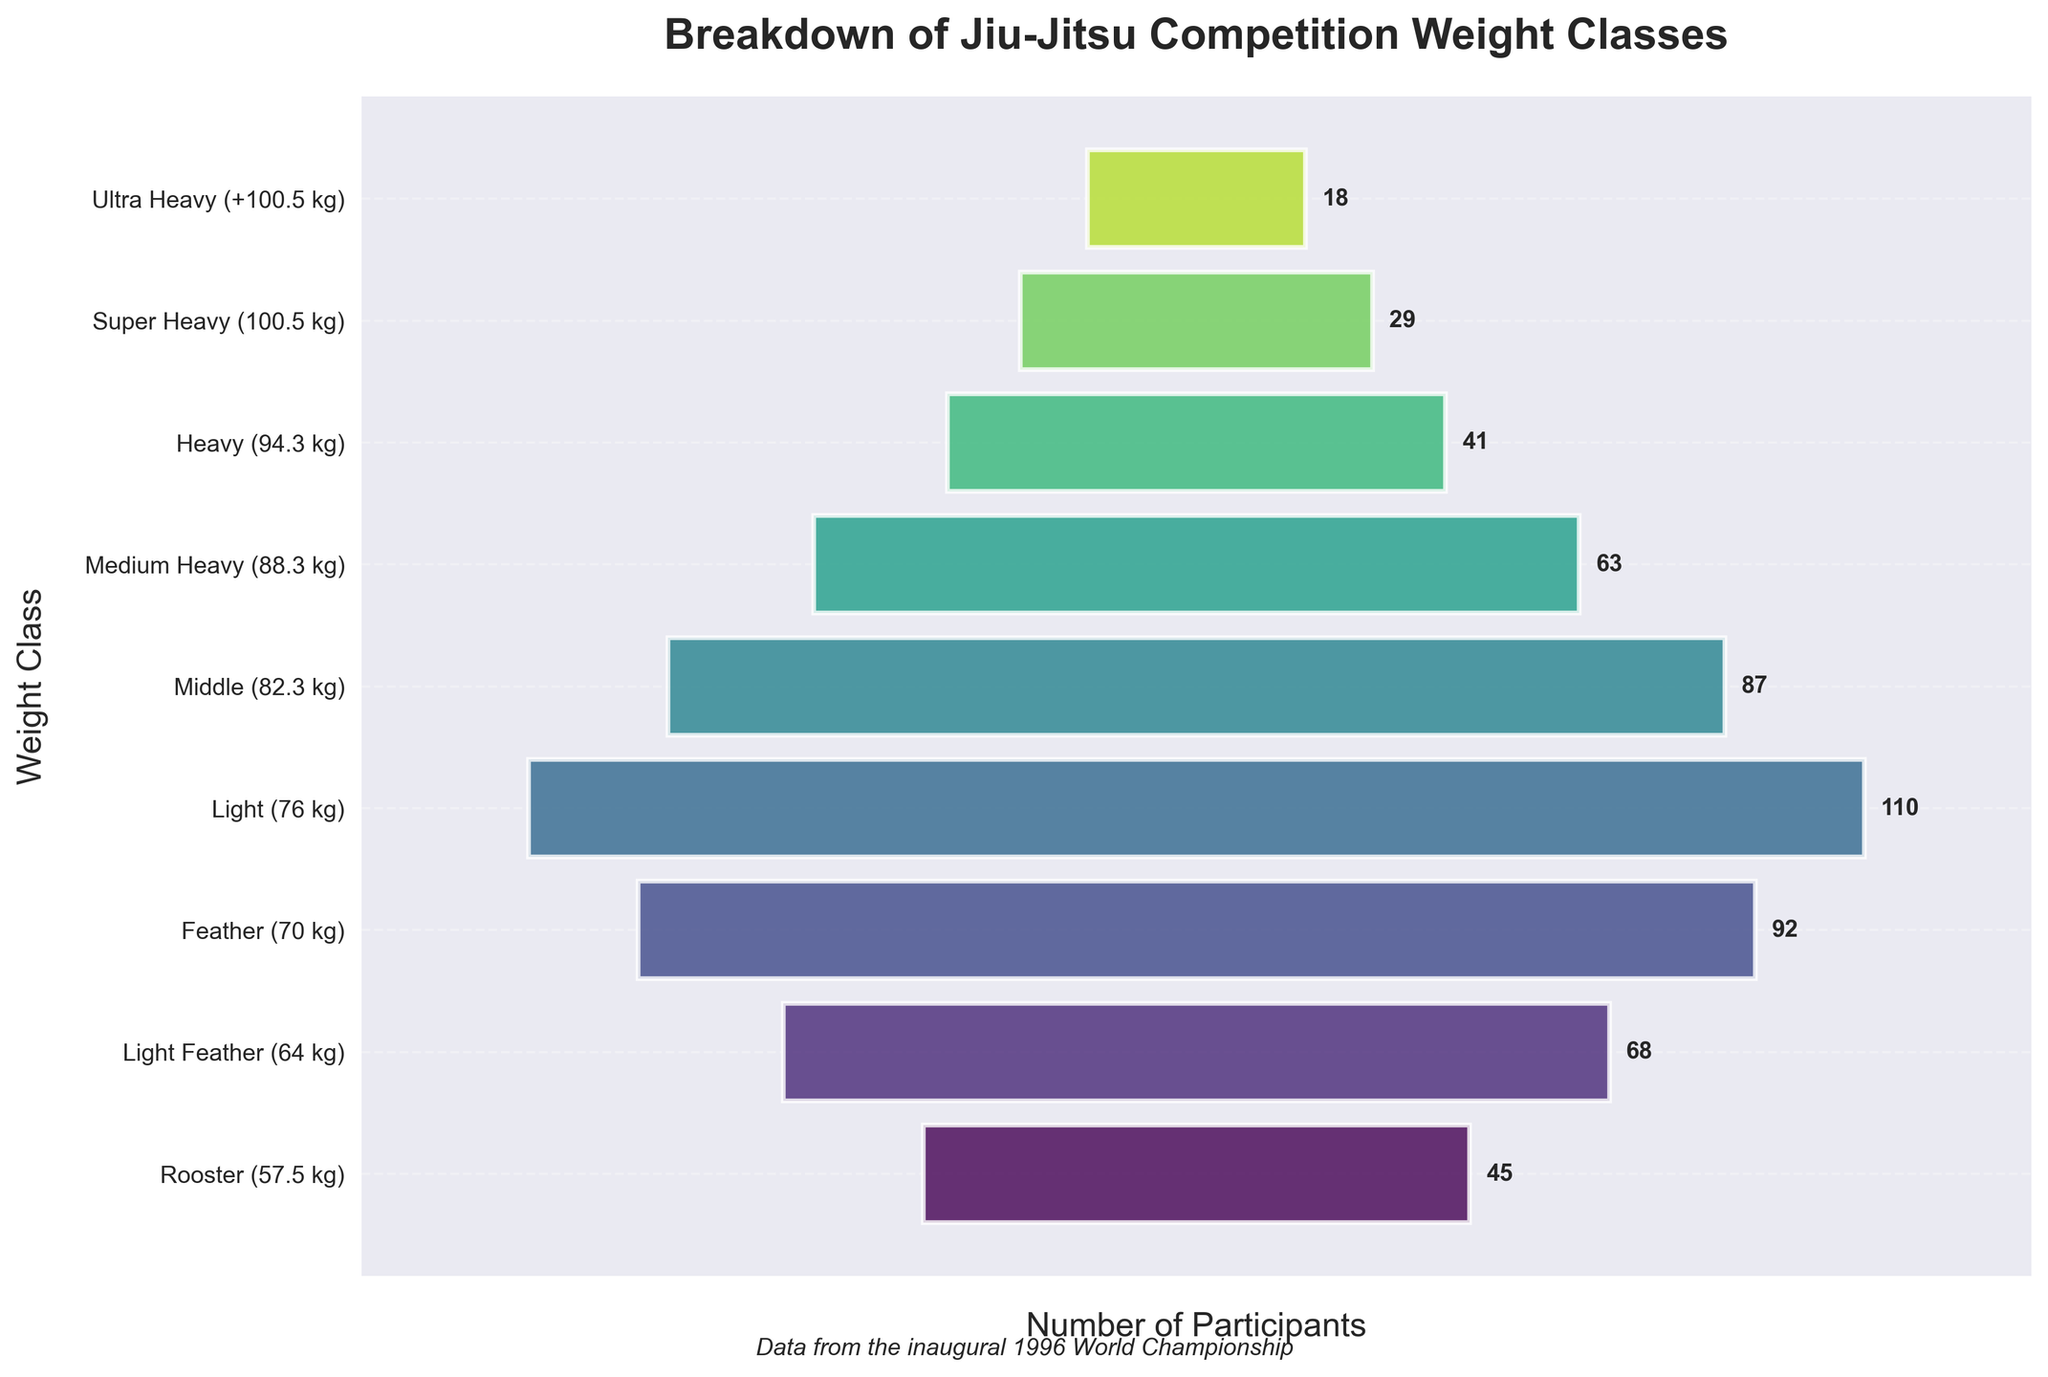What is the title of the chart? The title is written in large font at the top of the figure, describing the content of the chart.
Answer: Breakdown of Jiu-Jitsu Competition Weight Classes How many weight classes are represented in the chart? Count the number of horizontal bars representing different weight classes.
Answer: 9 Which weight class has the highest number of participants? Identify the bar that extends the furthest to the right, indicating the highest number of participants.
Answer: Light (76 kg) What's the combined number of participants in the Feather (70 kg) and Light (76 kg) weight classes? Add the number of participants in the Feather weight class (92) and the Light weight class (110).
Answer: 202 What is the weight class with the fewest participants? Identify the bar that extends the least to the right, indicating the fewest number of participants.
Answer: Ultra Heavy (+100.5 kg) How many participants are there in the Rooster (57.5 kg) weight class? Look for the number near the end of the bar corresponding to the Rooster weight class (57.5 kg).
Answer: 45 Is the number of participants in the Middle (82.3 kg) weight class greater than in the Medium Heavy (88.3 kg) weight class? Compare the number of participants in the Middle weight class (87) to that in the Medium Heavy weight class (63).
Answer: Yes How does the number of participants in the Heavy (94.3 kg) weight class compare to the Super Heavy (100.5 kg) weight class? Compare the number of participants in the Heavy weight class (41) to that in the Super Heavy weight class (29).
Answer: More What is the average number of participants across all weight classes? Add the number of participants in all weight classes and divide by the total number of weight classes. The sum is 45 + 68 + 92 + 110 + 87 + 63 + 41 + 29 + 18 = 553, then divide by 9.
Answer: 61.44 